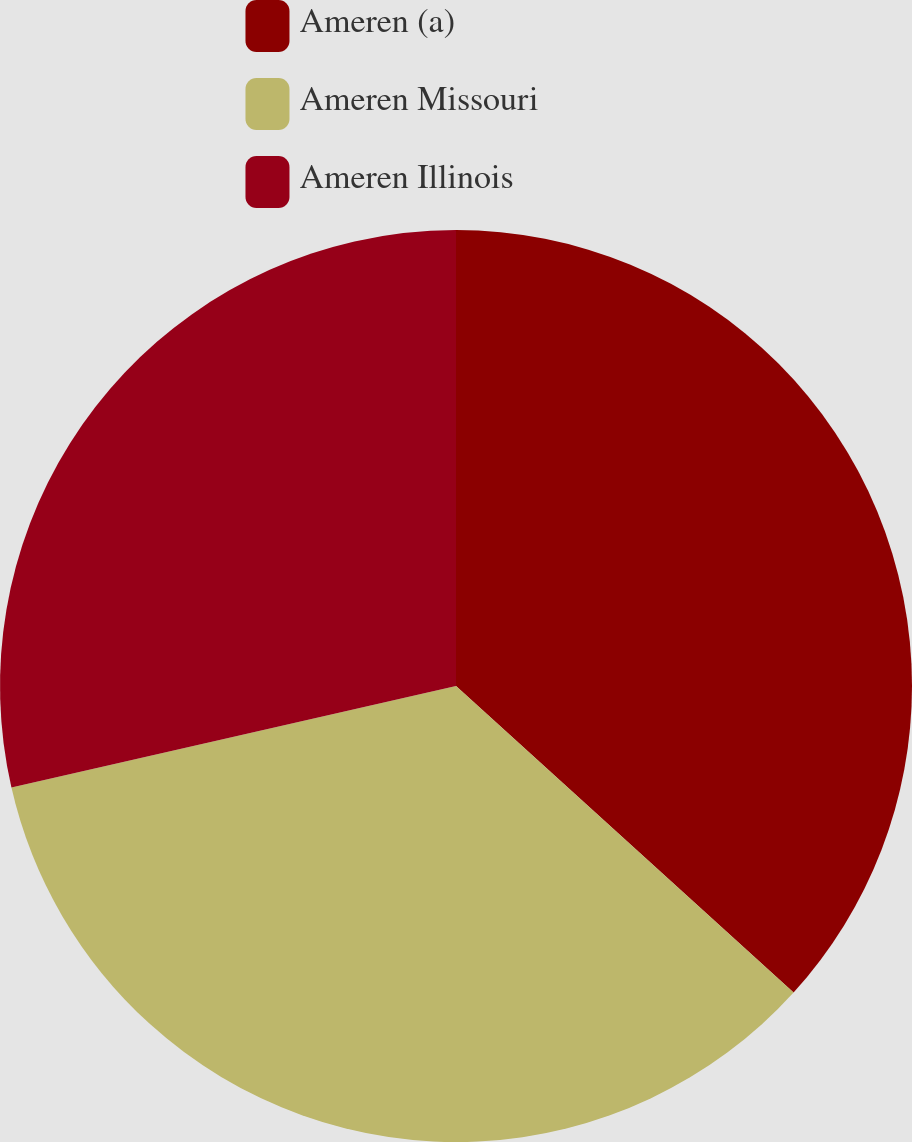Convert chart. <chart><loc_0><loc_0><loc_500><loc_500><pie_chart><fcel>Ameren (a)<fcel>Ameren Missouri<fcel>Ameren Illinois<nl><fcel>36.73%<fcel>34.69%<fcel>28.57%<nl></chart> 